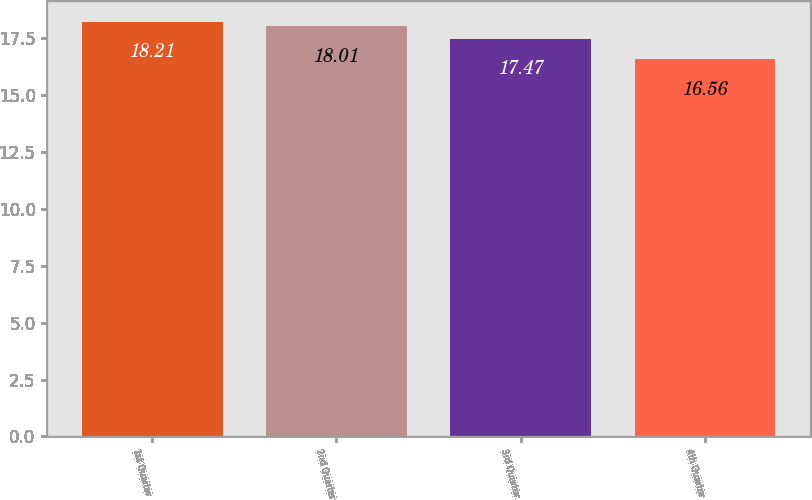<chart> <loc_0><loc_0><loc_500><loc_500><bar_chart><fcel>1st Quarter<fcel>2nd Quarter<fcel>3rd Quarter<fcel>4th Quarter<nl><fcel>18.21<fcel>18.01<fcel>17.47<fcel>16.56<nl></chart> 